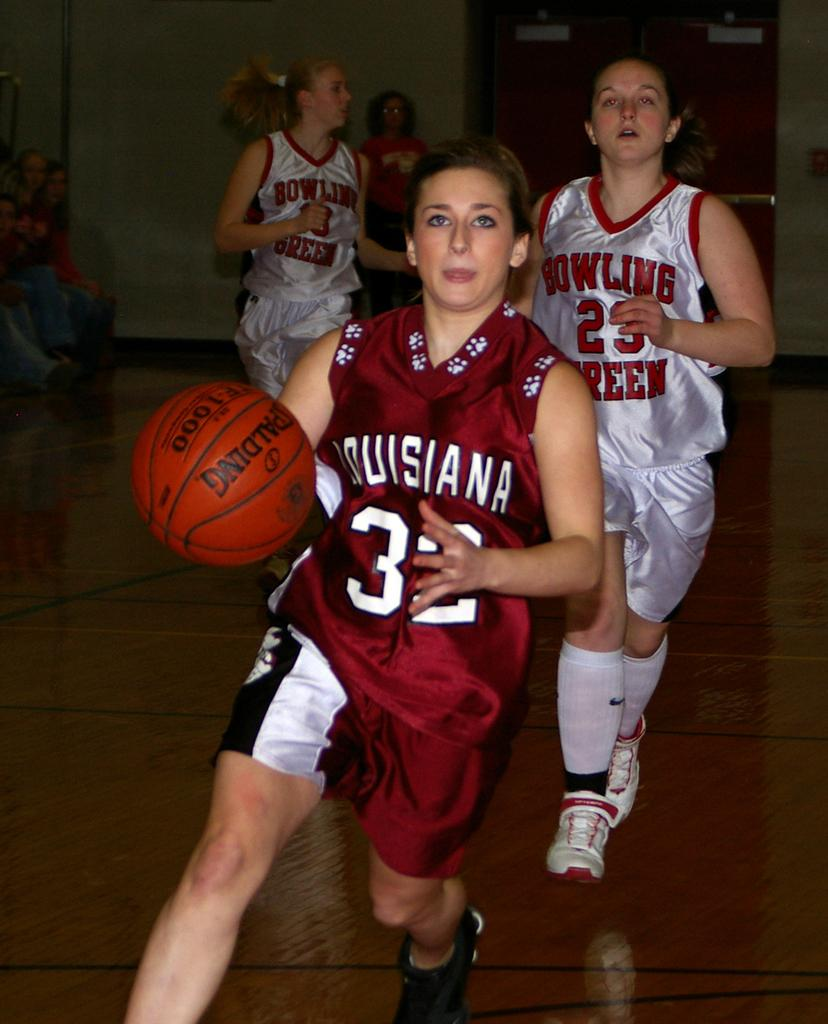Provide a one-sentence caption for the provided image. A girls game of basketball is underway, player 32 is in possession of the ball. 